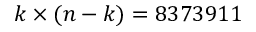<formula> <loc_0><loc_0><loc_500><loc_500>k \times ( n - k ) = 8 3 7 3 9 1 1</formula> 